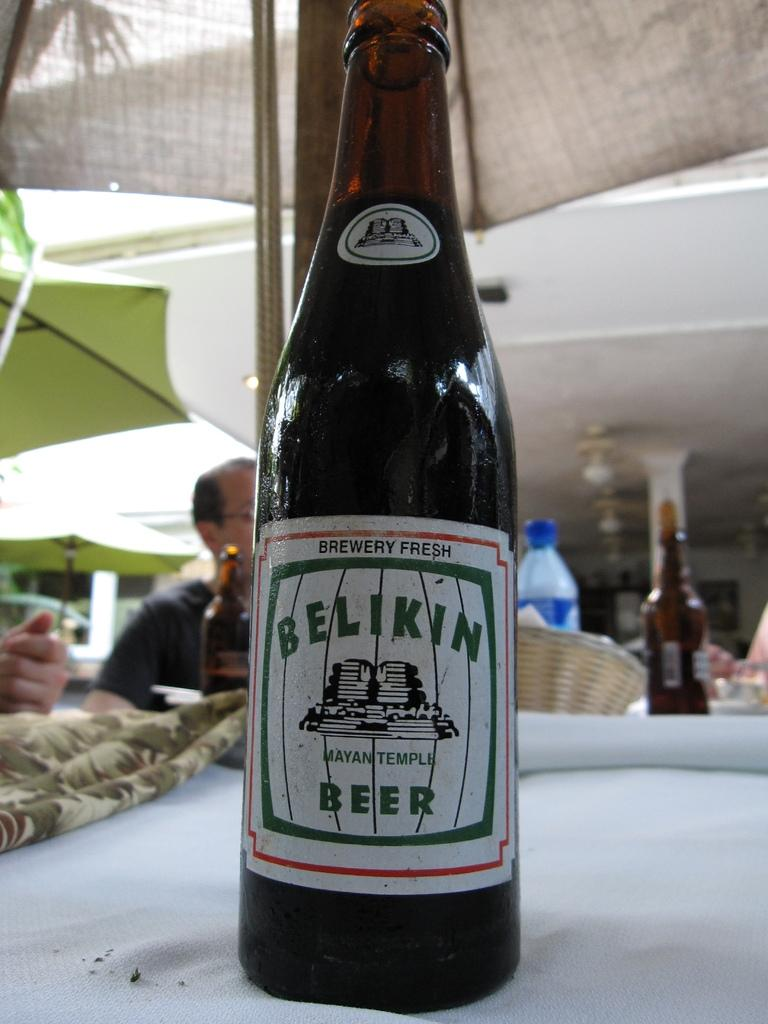<image>
Render a clear and concise summary of the photo. A bottle of Belkin beer claims to be brewery fresh. 